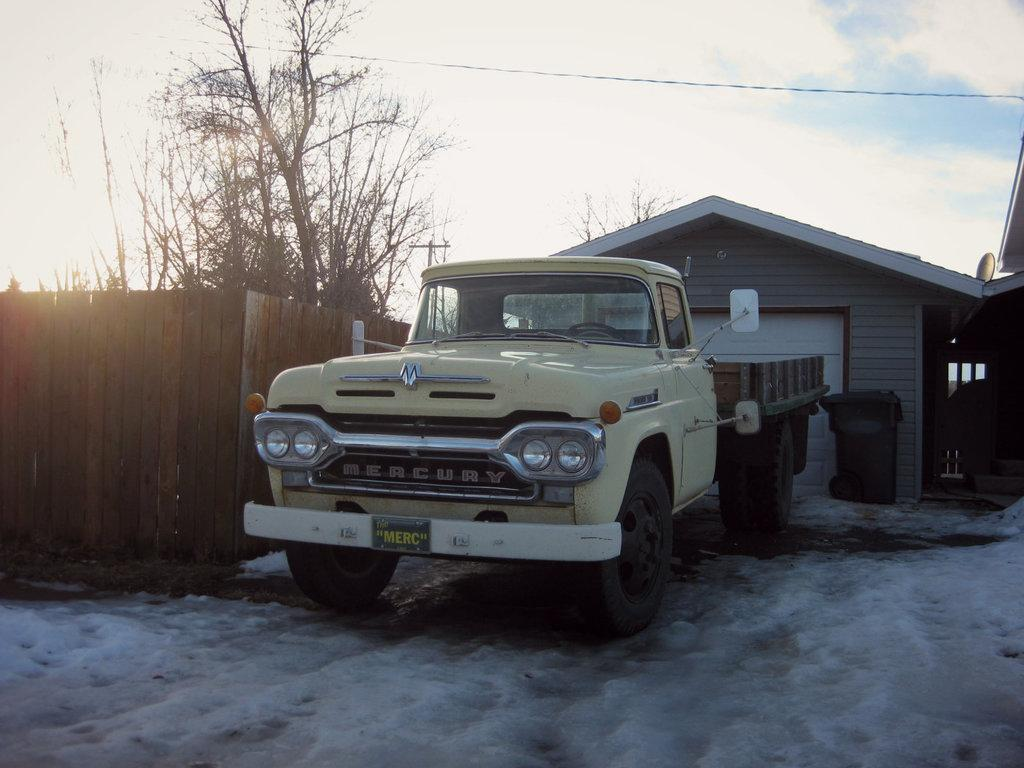<image>
Give a short and clear explanation of the subsequent image. The truck has been nicknamed "The Merc" according to the plate on the front. 